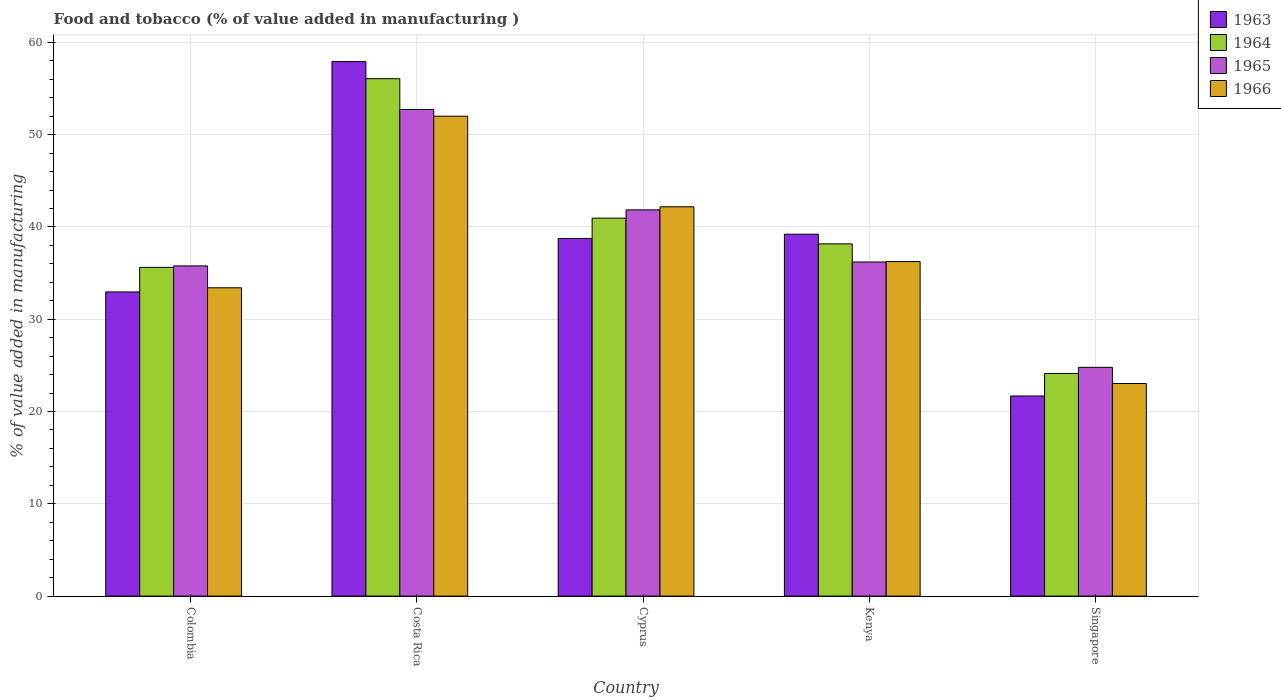Are the number of bars per tick equal to the number of legend labels?
Your answer should be very brief. Yes. What is the label of the 1st group of bars from the left?
Your response must be concise. Colombia. What is the value added in manufacturing food and tobacco in 1966 in Costa Rica?
Make the answer very short. 52. Across all countries, what is the maximum value added in manufacturing food and tobacco in 1966?
Offer a terse response. 52. Across all countries, what is the minimum value added in manufacturing food and tobacco in 1963?
Ensure brevity in your answer.  21.69. In which country was the value added in manufacturing food and tobacco in 1966 maximum?
Provide a short and direct response. Costa Rica. In which country was the value added in manufacturing food and tobacco in 1963 minimum?
Offer a very short reply. Singapore. What is the total value added in manufacturing food and tobacco in 1966 in the graph?
Offer a very short reply. 186.89. What is the difference between the value added in manufacturing food and tobacco in 1966 in Cyprus and that in Kenya?
Your response must be concise. 5.93. What is the difference between the value added in manufacturing food and tobacco in 1963 in Costa Rica and the value added in manufacturing food and tobacco in 1966 in Cyprus?
Ensure brevity in your answer.  15.73. What is the average value added in manufacturing food and tobacco in 1963 per country?
Provide a succinct answer. 38.11. What is the difference between the value added in manufacturing food and tobacco of/in 1966 and value added in manufacturing food and tobacco of/in 1964 in Colombia?
Make the answer very short. -2.21. In how many countries, is the value added in manufacturing food and tobacco in 1963 greater than 42 %?
Keep it short and to the point. 1. What is the ratio of the value added in manufacturing food and tobacco in 1965 in Colombia to that in Costa Rica?
Provide a short and direct response. 0.68. Is the value added in manufacturing food and tobacco in 1963 in Cyprus less than that in Kenya?
Ensure brevity in your answer.  Yes. Is the difference between the value added in manufacturing food and tobacco in 1966 in Colombia and Cyprus greater than the difference between the value added in manufacturing food and tobacco in 1964 in Colombia and Cyprus?
Provide a short and direct response. No. What is the difference between the highest and the second highest value added in manufacturing food and tobacco in 1963?
Ensure brevity in your answer.  19.17. What is the difference between the highest and the lowest value added in manufacturing food and tobacco in 1966?
Your answer should be very brief. 28.97. Is the sum of the value added in manufacturing food and tobacco in 1966 in Colombia and Singapore greater than the maximum value added in manufacturing food and tobacco in 1963 across all countries?
Your answer should be very brief. No. Is it the case that in every country, the sum of the value added in manufacturing food and tobacco in 1964 and value added in manufacturing food and tobacco in 1963 is greater than the sum of value added in manufacturing food and tobacco in 1966 and value added in manufacturing food and tobacco in 1965?
Your response must be concise. No. What does the 2nd bar from the left in Singapore represents?
Ensure brevity in your answer.  1964. What does the 1st bar from the right in Costa Rica represents?
Your response must be concise. 1966. Are the values on the major ticks of Y-axis written in scientific E-notation?
Offer a very short reply. No. Does the graph contain any zero values?
Your response must be concise. No. Does the graph contain grids?
Offer a terse response. Yes. What is the title of the graph?
Keep it short and to the point. Food and tobacco (% of value added in manufacturing ). What is the label or title of the Y-axis?
Offer a very short reply. % of value added in manufacturing. What is the % of value added in manufacturing in 1963 in Colombia?
Your response must be concise. 32.96. What is the % of value added in manufacturing of 1964 in Colombia?
Make the answer very short. 35.62. What is the % of value added in manufacturing in 1965 in Colombia?
Ensure brevity in your answer.  35.78. What is the % of value added in manufacturing of 1966 in Colombia?
Provide a short and direct response. 33.41. What is the % of value added in manufacturing in 1963 in Costa Rica?
Give a very brief answer. 57.92. What is the % of value added in manufacturing of 1964 in Costa Rica?
Offer a very short reply. 56.07. What is the % of value added in manufacturing in 1965 in Costa Rica?
Provide a short and direct response. 52.73. What is the % of value added in manufacturing in 1966 in Costa Rica?
Offer a very short reply. 52. What is the % of value added in manufacturing in 1963 in Cyprus?
Offer a terse response. 38.75. What is the % of value added in manufacturing of 1964 in Cyprus?
Your answer should be very brief. 40.96. What is the % of value added in manufacturing in 1965 in Cyprus?
Your answer should be very brief. 41.85. What is the % of value added in manufacturing in 1966 in Cyprus?
Your answer should be compact. 42.19. What is the % of value added in manufacturing in 1963 in Kenya?
Offer a terse response. 39.22. What is the % of value added in manufacturing of 1964 in Kenya?
Ensure brevity in your answer.  38.17. What is the % of value added in manufacturing of 1965 in Kenya?
Provide a succinct answer. 36.2. What is the % of value added in manufacturing in 1966 in Kenya?
Your answer should be compact. 36.25. What is the % of value added in manufacturing of 1963 in Singapore?
Provide a succinct answer. 21.69. What is the % of value added in manufacturing in 1964 in Singapore?
Ensure brevity in your answer.  24.13. What is the % of value added in manufacturing of 1965 in Singapore?
Provide a succinct answer. 24.79. What is the % of value added in manufacturing in 1966 in Singapore?
Your response must be concise. 23.04. Across all countries, what is the maximum % of value added in manufacturing in 1963?
Your answer should be very brief. 57.92. Across all countries, what is the maximum % of value added in manufacturing of 1964?
Your answer should be compact. 56.07. Across all countries, what is the maximum % of value added in manufacturing of 1965?
Give a very brief answer. 52.73. Across all countries, what is the maximum % of value added in manufacturing of 1966?
Provide a succinct answer. 52. Across all countries, what is the minimum % of value added in manufacturing of 1963?
Provide a succinct answer. 21.69. Across all countries, what is the minimum % of value added in manufacturing of 1964?
Ensure brevity in your answer.  24.13. Across all countries, what is the minimum % of value added in manufacturing in 1965?
Give a very brief answer. 24.79. Across all countries, what is the minimum % of value added in manufacturing in 1966?
Your response must be concise. 23.04. What is the total % of value added in manufacturing of 1963 in the graph?
Offer a very short reply. 190.54. What is the total % of value added in manufacturing in 1964 in the graph?
Offer a terse response. 194.94. What is the total % of value added in manufacturing in 1965 in the graph?
Your response must be concise. 191.36. What is the total % of value added in manufacturing in 1966 in the graph?
Give a very brief answer. 186.89. What is the difference between the % of value added in manufacturing of 1963 in Colombia and that in Costa Rica?
Offer a terse response. -24.96. What is the difference between the % of value added in manufacturing of 1964 in Colombia and that in Costa Rica?
Your answer should be very brief. -20.45. What is the difference between the % of value added in manufacturing of 1965 in Colombia and that in Costa Rica?
Your answer should be compact. -16.95. What is the difference between the % of value added in manufacturing in 1966 in Colombia and that in Costa Rica?
Your answer should be compact. -18.59. What is the difference between the % of value added in manufacturing in 1963 in Colombia and that in Cyprus?
Make the answer very short. -5.79. What is the difference between the % of value added in manufacturing of 1964 in Colombia and that in Cyprus?
Ensure brevity in your answer.  -5.34. What is the difference between the % of value added in manufacturing in 1965 in Colombia and that in Cyprus?
Keep it short and to the point. -6.07. What is the difference between the % of value added in manufacturing in 1966 in Colombia and that in Cyprus?
Give a very brief answer. -8.78. What is the difference between the % of value added in manufacturing in 1963 in Colombia and that in Kenya?
Offer a terse response. -6.26. What is the difference between the % of value added in manufacturing of 1964 in Colombia and that in Kenya?
Give a very brief answer. -2.55. What is the difference between the % of value added in manufacturing in 1965 in Colombia and that in Kenya?
Your response must be concise. -0.42. What is the difference between the % of value added in manufacturing in 1966 in Colombia and that in Kenya?
Your answer should be very brief. -2.84. What is the difference between the % of value added in manufacturing in 1963 in Colombia and that in Singapore?
Your answer should be very brief. 11.27. What is the difference between the % of value added in manufacturing in 1964 in Colombia and that in Singapore?
Offer a terse response. 11.49. What is the difference between the % of value added in manufacturing in 1965 in Colombia and that in Singapore?
Your response must be concise. 10.99. What is the difference between the % of value added in manufacturing of 1966 in Colombia and that in Singapore?
Keep it short and to the point. 10.37. What is the difference between the % of value added in manufacturing of 1963 in Costa Rica and that in Cyprus?
Your answer should be very brief. 19.17. What is the difference between the % of value added in manufacturing in 1964 in Costa Rica and that in Cyprus?
Provide a succinct answer. 15.11. What is the difference between the % of value added in manufacturing of 1965 in Costa Rica and that in Cyprus?
Offer a very short reply. 10.88. What is the difference between the % of value added in manufacturing of 1966 in Costa Rica and that in Cyprus?
Make the answer very short. 9.82. What is the difference between the % of value added in manufacturing of 1963 in Costa Rica and that in Kenya?
Make the answer very short. 18.7. What is the difference between the % of value added in manufacturing of 1964 in Costa Rica and that in Kenya?
Your answer should be compact. 17.9. What is the difference between the % of value added in manufacturing of 1965 in Costa Rica and that in Kenya?
Provide a succinct answer. 16.53. What is the difference between the % of value added in manufacturing in 1966 in Costa Rica and that in Kenya?
Provide a succinct answer. 15.75. What is the difference between the % of value added in manufacturing of 1963 in Costa Rica and that in Singapore?
Ensure brevity in your answer.  36.23. What is the difference between the % of value added in manufacturing in 1964 in Costa Rica and that in Singapore?
Your response must be concise. 31.94. What is the difference between the % of value added in manufacturing in 1965 in Costa Rica and that in Singapore?
Your answer should be compact. 27.94. What is the difference between the % of value added in manufacturing of 1966 in Costa Rica and that in Singapore?
Your answer should be very brief. 28.97. What is the difference between the % of value added in manufacturing of 1963 in Cyprus and that in Kenya?
Ensure brevity in your answer.  -0.46. What is the difference between the % of value added in manufacturing of 1964 in Cyprus and that in Kenya?
Ensure brevity in your answer.  2.79. What is the difference between the % of value added in manufacturing in 1965 in Cyprus and that in Kenya?
Your response must be concise. 5.65. What is the difference between the % of value added in manufacturing of 1966 in Cyprus and that in Kenya?
Make the answer very short. 5.93. What is the difference between the % of value added in manufacturing of 1963 in Cyprus and that in Singapore?
Keep it short and to the point. 17.07. What is the difference between the % of value added in manufacturing of 1964 in Cyprus and that in Singapore?
Provide a succinct answer. 16.83. What is the difference between the % of value added in manufacturing of 1965 in Cyprus and that in Singapore?
Ensure brevity in your answer.  17.06. What is the difference between the % of value added in manufacturing of 1966 in Cyprus and that in Singapore?
Offer a very short reply. 19.15. What is the difference between the % of value added in manufacturing in 1963 in Kenya and that in Singapore?
Your answer should be very brief. 17.53. What is the difference between the % of value added in manufacturing in 1964 in Kenya and that in Singapore?
Your answer should be very brief. 14.04. What is the difference between the % of value added in manufacturing in 1965 in Kenya and that in Singapore?
Your answer should be very brief. 11.41. What is the difference between the % of value added in manufacturing of 1966 in Kenya and that in Singapore?
Keep it short and to the point. 13.22. What is the difference between the % of value added in manufacturing in 1963 in Colombia and the % of value added in manufacturing in 1964 in Costa Rica?
Your answer should be compact. -23.11. What is the difference between the % of value added in manufacturing in 1963 in Colombia and the % of value added in manufacturing in 1965 in Costa Rica?
Your answer should be compact. -19.77. What is the difference between the % of value added in manufacturing in 1963 in Colombia and the % of value added in manufacturing in 1966 in Costa Rica?
Your answer should be compact. -19.04. What is the difference between the % of value added in manufacturing in 1964 in Colombia and the % of value added in manufacturing in 1965 in Costa Rica?
Provide a short and direct response. -17.11. What is the difference between the % of value added in manufacturing in 1964 in Colombia and the % of value added in manufacturing in 1966 in Costa Rica?
Provide a short and direct response. -16.38. What is the difference between the % of value added in manufacturing of 1965 in Colombia and the % of value added in manufacturing of 1966 in Costa Rica?
Offer a very short reply. -16.22. What is the difference between the % of value added in manufacturing in 1963 in Colombia and the % of value added in manufacturing in 1964 in Cyprus?
Offer a terse response. -8. What is the difference between the % of value added in manufacturing in 1963 in Colombia and the % of value added in manufacturing in 1965 in Cyprus?
Offer a terse response. -8.89. What is the difference between the % of value added in manufacturing in 1963 in Colombia and the % of value added in manufacturing in 1966 in Cyprus?
Your answer should be very brief. -9.23. What is the difference between the % of value added in manufacturing of 1964 in Colombia and the % of value added in manufacturing of 1965 in Cyprus?
Your answer should be very brief. -6.23. What is the difference between the % of value added in manufacturing in 1964 in Colombia and the % of value added in manufacturing in 1966 in Cyprus?
Your answer should be compact. -6.57. What is the difference between the % of value added in manufacturing in 1965 in Colombia and the % of value added in manufacturing in 1966 in Cyprus?
Make the answer very short. -6.41. What is the difference between the % of value added in manufacturing in 1963 in Colombia and the % of value added in manufacturing in 1964 in Kenya?
Offer a terse response. -5.21. What is the difference between the % of value added in manufacturing in 1963 in Colombia and the % of value added in manufacturing in 1965 in Kenya?
Provide a short and direct response. -3.24. What is the difference between the % of value added in manufacturing of 1963 in Colombia and the % of value added in manufacturing of 1966 in Kenya?
Keep it short and to the point. -3.29. What is the difference between the % of value added in manufacturing of 1964 in Colombia and the % of value added in manufacturing of 1965 in Kenya?
Keep it short and to the point. -0.58. What is the difference between the % of value added in manufacturing in 1964 in Colombia and the % of value added in manufacturing in 1966 in Kenya?
Your response must be concise. -0.63. What is the difference between the % of value added in manufacturing of 1965 in Colombia and the % of value added in manufacturing of 1966 in Kenya?
Your answer should be very brief. -0.47. What is the difference between the % of value added in manufacturing in 1963 in Colombia and the % of value added in manufacturing in 1964 in Singapore?
Offer a very short reply. 8.83. What is the difference between the % of value added in manufacturing in 1963 in Colombia and the % of value added in manufacturing in 1965 in Singapore?
Provide a succinct answer. 8.17. What is the difference between the % of value added in manufacturing in 1963 in Colombia and the % of value added in manufacturing in 1966 in Singapore?
Your answer should be compact. 9.92. What is the difference between the % of value added in manufacturing of 1964 in Colombia and the % of value added in manufacturing of 1965 in Singapore?
Your response must be concise. 10.83. What is the difference between the % of value added in manufacturing of 1964 in Colombia and the % of value added in manufacturing of 1966 in Singapore?
Provide a short and direct response. 12.58. What is the difference between the % of value added in manufacturing of 1965 in Colombia and the % of value added in manufacturing of 1966 in Singapore?
Give a very brief answer. 12.74. What is the difference between the % of value added in manufacturing in 1963 in Costa Rica and the % of value added in manufacturing in 1964 in Cyprus?
Make the answer very short. 16.96. What is the difference between the % of value added in manufacturing of 1963 in Costa Rica and the % of value added in manufacturing of 1965 in Cyprus?
Your answer should be very brief. 16.07. What is the difference between the % of value added in manufacturing in 1963 in Costa Rica and the % of value added in manufacturing in 1966 in Cyprus?
Provide a succinct answer. 15.73. What is the difference between the % of value added in manufacturing of 1964 in Costa Rica and the % of value added in manufacturing of 1965 in Cyprus?
Your answer should be very brief. 14.21. What is the difference between the % of value added in manufacturing in 1964 in Costa Rica and the % of value added in manufacturing in 1966 in Cyprus?
Offer a very short reply. 13.88. What is the difference between the % of value added in manufacturing of 1965 in Costa Rica and the % of value added in manufacturing of 1966 in Cyprus?
Your response must be concise. 10.55. What is the difference between the % of value added in manufacturing of 1963 in Costa Rica and the % of value added in manufacturing of 1964 in Kenya?
Your answer should be compact. 19.75. What is the difference between the % of value added in manufacturing of 1963 in Costa Rica and the % of value added in manufacturing of 1965 in Kenya?
Give a very brief answer. 21.72. What is the difference between the % of value added in manufacturing in 1963 in Costa Rica and the % of value added in manufacturing in 1966 in Kenya?
Your answer should be compact. 21.67. What is the difference between the % of value added in manufacturing in 1964 in Costa Rica and the % of value added in manufacturing in 1965 in Kenya?
Offer a very short reply. 19.86. What is the difference between the % of value added in manufacturing of 1964 in Costa Rica and the % of value added in manufacturing of 1966 in Kenya?
Provide a short and direct response. 19.81. What is the difference between the % of value added in manufacturing in 1965 in Costa Rica and the % of value added in manufacturing in 1966 in Kenya?
Your answer should be very brief. 16.48. What is the difference between the % of value added in manufacturing of 1963 in Costa Rica and the % of value added in manufacturing of 1964 in Singapore?
Keep it short and to the point. 33.79. What is the difference between the % of value added in manufacturing of 1963 in Costa Rica and the % of value added in manufacturing of 1965 in Singapore?
Ensure brevity in your answer.  33.13. What is the difference between the % of value added in manufacturing in 1963 in Costa Rica and the % of value added in manufacturing in 1966 in Singapore?
Provide a succinct answer. 34.88. What is the difference between the % of value added in manufacturing of 1964 in Costa Rica and the % of value added in manufacturing of 1965 in Singapore?
Keep it short and to the point. 31.28. What is the difference between the % of value added in manufacturing of 1964 in Costa Rica and the % of value added in manufacturing of 1966 in Singapore?
Your answer should be very brief. 33.03. What is the difference between the % of value added in manufacturing of 1965 in Costa Rica and the % of value added in manufacturing of 1966 in Singapore?
Keep it short and to the point. 29.7. What is the difference between the % of value added in manufacturing of 1963 in Cyprus and the % of value added in manufacturing of 1964 in Kenya?
Offer a terse response. 0.59. What is the difference between the % of value added in manufacturing in 1963 in Cyprus and the % of value added in manufacturing in 1965 in Kenya?
Keep it short and to the point. 2.55. What is the difference between the % of value added in manufacturing of 1963 in Cyprus and the % of value added in manufacturing of 1966 in Kenya?
Give a very brief answer. 2.5. What is the difference between the % of value added in manufacturing in 1964 in Cyprus and the % of value added in manufacturing in 1965 in Kenya?
Ensure brevity in your answer.  4.75. What is the difference between the % of value added in manufacturing in 1964 in Cyprus and the % of value added in manufacturing in 1966 in Kenya?
Keep it short and to the point. 4.7. What is the difference between the % of value added in manufacturing of 1965 in Cyprus and the % of value added in manufacturing of 1966 in Kenya?
Provide a succinct answer. 5.6. What is the difference between the % of value added in manufacturing of 1963 in Cyprus and the % of value added in manufacturing of 1964 in Singapore?
Offer a very short reply. 14.63. What is the difference between the % of value added in manufacturing of 1963 in Cyprus and the % of value added in manufacturing of 1965 in Singapore?
Keep it short and to the point. 13.96. What is the difference between the % of value added in manufacturing in 1963 in Cyprus and the % of value added in manufacturing in 1966 in Singapore?
Offer a terse response. 15.72. What is the difference between the % of value added in manufacturing of 1964 in Cyprus and the % of value added in manufacturing of 1965 in Singapore?
Your answer should be compact. 16.17. What is the difference between the % of value added in manufacturing in 1964 in Cyprus and the % of value added in manufacturing in 1966 in Singapore?
Your answer should be compact. 17.92. What is the difference between the % of value added in manufacturing of 1965 in Cyprus and the % of value added in manufacturing of 1966 in Singapore?
Make the answer very short. 18.82. What is the difference between the % of value added in manufacturing of 1963 in Kenya and the % of value added in manufacturing of 1964 in Singapore?
Offer a terse response. 15.09. What is the difference between the % of value added in manufacturing of 1963 in Kenya and the % of value added in manufacturing of 1965 in Singapore?
Your answer should be very brief. 14.43. What is the difference between the % of value added in manufacturing of 1963 in Kenya and the % of value added in manufacturing of 1966 in Singapore?
Offer a terse response. 16.18. What is the difference between the % of value added in manufacturing of 1964 in Kenya and the % of value added in manufacturing of 1965 in Singapore?
Your response must be concise. 13.38. What is the difference between the % of value added in manufacturing in 1964 in Kenya and the % of value added in manufacturing in 1966 in Singapore?
Give a very brief answer. 15.13. What is the difference between the % of value added in manufacturing of 1965 in Kenya and the % of value added in manufacturing of 1966 in Singapore?
Give a very brief answer. 13.17. What is the average % of value added in manufacturing in 1963 per country?
Provide a short and direct response. 38.11. What is the average % of value added in manufacturing in 1964 per country?
Offer a very short reply. 38.99. What is the average % of value added in manufacturing in 1965 per country?
Your response must be concise. 38.27. What is the average % of value added in manufacturing in 1966 per country?
Your answer should be compact. 37.38. What is the difference between the % of value added in manufacturing of 1963 and % of value added in manufacturing of 1964 in Colombia?
Keep it short and to the point. -2.66. What is the difference between the % of value added in manufacturing in 1963 and % of value added in manufacturing in 1965 in Colombia?
Give a very brief answer. -2.82. What is the difference between the % of value added in manufacturing in 1963 and % of value added in manufacturing in 1966 in Colombia?
Keep it short and to the point. -0.45. What is the difference between the % of value added in manufacturing in 1964 and % of value added in manufacturing in 1965 in Colombia?
Your response must be concise. -0.16. What is the difference between the % of value added in manufacturing of 1964 and % of value added in manufacturing of 1966 in Colombia?
Give a very brief answer. 2.21. What is the difference between the % of value added in manufacturing in 1965 and % of value added in manufacturing in 1966 in Colombia?
Provide a succinct answer. 2.37. What is the difference between the % of value added in manufacturing of 1963 and % of value added in manufacturing of 1964 in Costa Rica?
Provide a succinct answer. 1.85. What is the difference between the % of value added in manufacturing of 1963 and % of value added in manufacturing of 1965 in Costa Rica?
Your answer should be compact. 5.19. What is the difference between the % of value added in manufacturing in 1963 and % of value added in manufacturing in 1966 in Costa Rica?
Make the answer very short. 5.92. What is the difference between the % of value added in manufacturing in 1964 and % of value added in manufacturing in 1965 in Costa Rica?
Provide a succinct answer. 3.33. What is the difference between the % of value added in manufacturing of 1964 and % of value added in manufacturing of 1966 in Costa Rica?
Make the answer very short. 4.06. What is the difference between the % of value added in manufacturing in 1965 and % of value added in manufacturing in 1966 in Costa Rica?
Your answer should be compact. 0.73. What is the difference between the % of value added in manufacturing in 1963 and % of value added in manufacturing in 1964 in Cyprus?
Your answer should be compact. -2.2. What is the difference between the % of value added in manufacturing of 1963 and % of value added in manufacturing of 1965 in Cyprus?
Your answer should be compact. -3.1. What is the difference between the % of value added in manufacturing in 1963 and % of value added in manufacturing in 1966 in Cyprus?
Your response must be concise. -3.43. What is the difference between the % of value added in manufacturing in 1964 and % of value added in manufacturing in 1965 in Cyprus?
Provide a succinct answer. -0.9. What is the difference between the % of value added in manufacturing of 1964 and % of value added in manufacturing of 1966 in Cyprus?
Offer a terse response. -1.23. What is the difference between the % of value added in manufacturing in 1963 and % of value added in manufacturing in 1964 in Kenya?
Your answer should be very brief. 1.05. What is the difference between the % of value added in manufacturing of 1963 and % of value added in manufacturing of 1965 in Kenya?
Provide a succinct answer. 3.01. What is the difference between the % of value added in manufacturing of 1963 and % of value added in manufacturing of 1966 in Kenya?
Your response must be concise. 2.96. What is the difference between the % of value added in manufacturing of 1964 and % of value added in manufacturing of 1965 in Kenya?
Offer a terse response. 1.96. What is the difference between the % of value added in manufacturing in 1964 and % of value added in manufacturing in 1966 in Kenya?
Provide a short and direct response. 1.91. What is the difference between the % of value added in manufacturing of 1963 and % of value added in manufacturing of 1964 in Singapore?
Your response must be concise. -2.44. What is the difference between the % of value added in manufacturing of 1963 and % of value added in manufacturing of 1965 in Singapore?
Provide a succinct answer. -3.1. What is the difference between the % of value added in manufacturing in 1963 and % of value added in manufacturing in 1966 in Singapore?
Your response must be concise. -1.35. What is the difference between the % of value added in manufacturing in 1964 and % of value added in manufacturing in 1965 in Singapore?
Give a very brief answer. -0.66. What is the difference between the % of value added in manufacturing of 1964 and % of value added in manufacturing of 1966 in Singapore?
Provide a short and direct response. 1.09. What is the difference between the % of value added in manufacturing in 1965 and % of value added in manufacturing in 1966 in Singapore?
Your answer should be compact. 1.75. What is the ratio of the % of value added in manufacturing in 1963 in Colombia to that in Costa Rica?
Offer a terse response. 0.57. What is the ratio of the % of value added in manufacturing of 1964 in Colombia to that in Costa Rica?
Provide a succinct answer. 0.64. What is the ratio of the % of value added in manufacturing of 1965 in Colombia to that in Costa Rica?
Give a very brief answer. 0.68. What is the ratio of the % of value added in manufacturing of 1966 in Colombia to that in Costa Rica?
Your answer should be compact. 0.64. What is the ratio of the % of value added in manufacturing in 1963 in Colombia to that in Cyprus?
Offer a terse response. 0.85. What is the ratio of the % of value added in manufacturing of 1964 in Colombia to that in Cyprus?
Offer a terse response. 0.87. What is the ratio of the % of value added in manufacturing of 1965 in Colombia to that in Cyprus?
Offer a very short reply. 0.85. What is the ratio of the % of value added in manufacturing of 1966 in Colombia to that in Cyprus?
Your answer should be very brief. 0.79. What is the ratio of the % of value added in manufacturing of 1963 in Colombia to that in Kenya?
Ensure brevity in your answer.  0.84. What is the ratio of the % of value added in manufacturing in 1964 in Colombia to that in Kenya?
Provide a short and direct response. 0.93. What is the ratio of the % of value added in manufacturing in 1965 in Colombia to that in Kenya?
Your answer should be very brief. 0.99. What is the ratio of the % of value added in manufacturing of 1966 in Colombia to that in Kenya?
Offer a terse response. 0.92. What is the ratio of the % of value added in manufacturing of 1963 in Colombia to that in Singapore?
Provide a short and direct response. 1.52. What is the ratio of the % of value added in manufacturing of 1964 in Colombia to that in Singapore?
Your answer should be compact. 1.48. What is the ratio of the % of value added in manufacturing in 1965 in Colombia to that in Singapore?
Your answer should be very brief. 1.44. What is the ratio of the % of value added in manufacturing of 1966 in Colombia to that in Singapore?
Your response must be concise. 1.45. What is the ratio of the % of value added in manufacturing in 1963 in Costa Rica to that in Cyprus?
Your response must be concise. 1.49. What is the ratio of the % of value added in manufacturing of 1964 in Costa Rica to that in Cyprus?
Offer a terse response. 1.37. What is the ratio of the % of value added in manufacturing of 1965 in Costa Rica to that in Cyprus?
Keep it short and to the point. 1.26. What is the ratio of the % of value added in manufacturing in 1966 in Costa Rica to that in Cyprus?
Ensure brevity in your answer.  1.23. What is the ratio of the % of value added in manufacturing in 1963 in Costa Rica to that in Kenya?
Ensure brevity in your answer.  1.48. What is the ratio of the % of value added in manufacturing in 1964 in Costa Rica to that in Kenya?
Provide a succinct answer. 1.47. What is the ratio of the % of value added in manufacturing in 1965 in Costa Rica to that in Kenya?
Your answer should be very brief. 1.46. What is the ratio of the % of value added in manufacturing in 1966 in Costa Rica to that in Kenya?
Your answer should be very brief. 1.43. What is the ratio of the % of value added in manufacturing in 1963 in Costa Rica to that in Singapore?
Make the answer very short. 2.67. What is the ratio of the % of value added in manufacturing of 1964 in Costa Rica to that in Singapore?
Your answer should be compact. 2.32. What is the ratio of the % of value added in manufacturing of 1965 in Costa Rica to that in Singapore?
Offer a very short reply. 2.13. What is the ratio of the % of value added in manufacturing in 1966 in Costa Rica to that in Singapore?
Provide a short and direct response. 2.26. What is the ratio of the % of value added in manufacturing of 1963 in Cyprus to that in Kenya?
Keep it short and to the point. 0.99. What is the ratio of the % of value added in manufacturing in 1964 in Cyprus to that in Kenya?
Provide a short and direct response. 1.07. What is the ratio of the % of value added in manufacturing in 1965 in Cyprus to that in Kenya?
Provide a short and direct response. 1.16. What is the ratio of the % of value added in manufacturing of 1966 in Cyprus to that in Kenya?
Your response must be concise. 1.16. What is the ratio of the % of value added in manufacturing in 1963 in Cyprus to that in Singapore?
Give a very brief answer. 1.79. What is the ratio of the % of value added in manufacturing in 1964 in Cyprus to that in Singapore?
Your response must be concise. 1.7. What is the ratio of the % of value added in manufacturing in 1965 in Cyprus to that in Singapore?
Offer a terse response. 1.69. What is the ratio of the % of value added in manufacturing of 1966 in Cyprus to that in Singapore?
Ensure brevity in your answer.  1.83. What is the ratio of the % of value added in manufacturing in 1963 in Kenya to that in Singapore?
Ensure brevity in your answer.  1.81. What is the ratio of the % of value added in manufacturing of 1964 in Kenya to that in Singapore?
Offer a very short reply. 1.58. What is the ratio of the % of value added in manufacturing in 1965 in Kenya to that in Singapore?
Offer a terse response. 1.46. What is the ratio of the % of value added in manufacturing of 1966 in Kenya to that in Singapore?
Offer a very short reply. 1.57. What is the difference between the highest and the second highest % of value added in manufacturing in 1963?
Ensure brevity in your answer.  18.7. What is the difference between the highest and the second highest % of value added in manufacturing in 1964?
Your answer should be compact. 15.11. What is the difference between the highest and the second highest % of value added in manufacturing in 1965?
Keep it short and to the point. 10.88. What is the difference between the highest and the second highest % of value added in manufacturing in 1966?
Provide a succinct answer. 9.82. What is the difference between the highest and the lowest % of value added in manufacturing in 1963?
Make the answer very short. 36.23. What is the difference between the highest and the lowest % of value added in manufacturing of 1964?
Give a very brief answer. 31.94. What is the difference between the highest and the lowest % of value added in manufacturing in 1965?
Your answer should be very brief. 27.94. What is the difference between the highest and the lowest % of value added in manufacturing of 1966?
Provide a succinct answer. 28.97. 